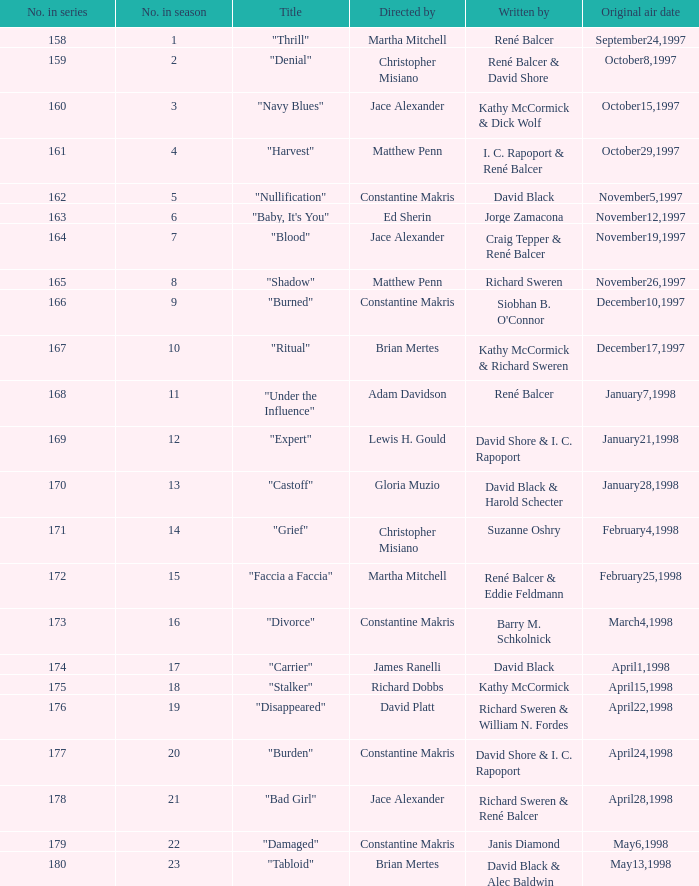Identify the episode which was directed by ed sherin. "Baby, It's You". 